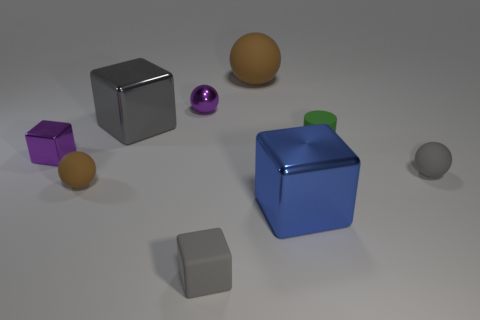Do the small purple object on the left side of the tiny brown rubber ball and the blue cube have the same material?
Your answer should be very brief. Yes. What is the shape of the green object that is the same size as the gray sphere?
Your answer should be compact. Cylinder. How many tiny metallic things are the same color as the tiny metal cube?
Offer a terse response. 1. Are there fewer large blue objects that are left of the small metallic block than small gray spheres that are behind the small purple metallic ball?
Provide a short and direct response. No. There is a big gray block; are there any green matte things on the left side of it?
Your answer should be very brief. No. Are there any blue metallic things that are right of the large blue object on the right side of the rubber sphere that is on the left side of the gray matte block?
Your answer should be compact. No. There is a tiny purple object that is on the left side of the tiny brown rubber ball; is its shape the same as the large brown matte object?
Keep it short and to the point. No. What color is the cube that is the same material as the tiny cylinder?
Your response must be concise. Gray. What number of blue cubes have the same material as the purple block?
Offer a very short reply. 1. What color is the block in front of the big shiny object in front of the gray object behind the purple metallic block?
Make the answer very short. Gray. 